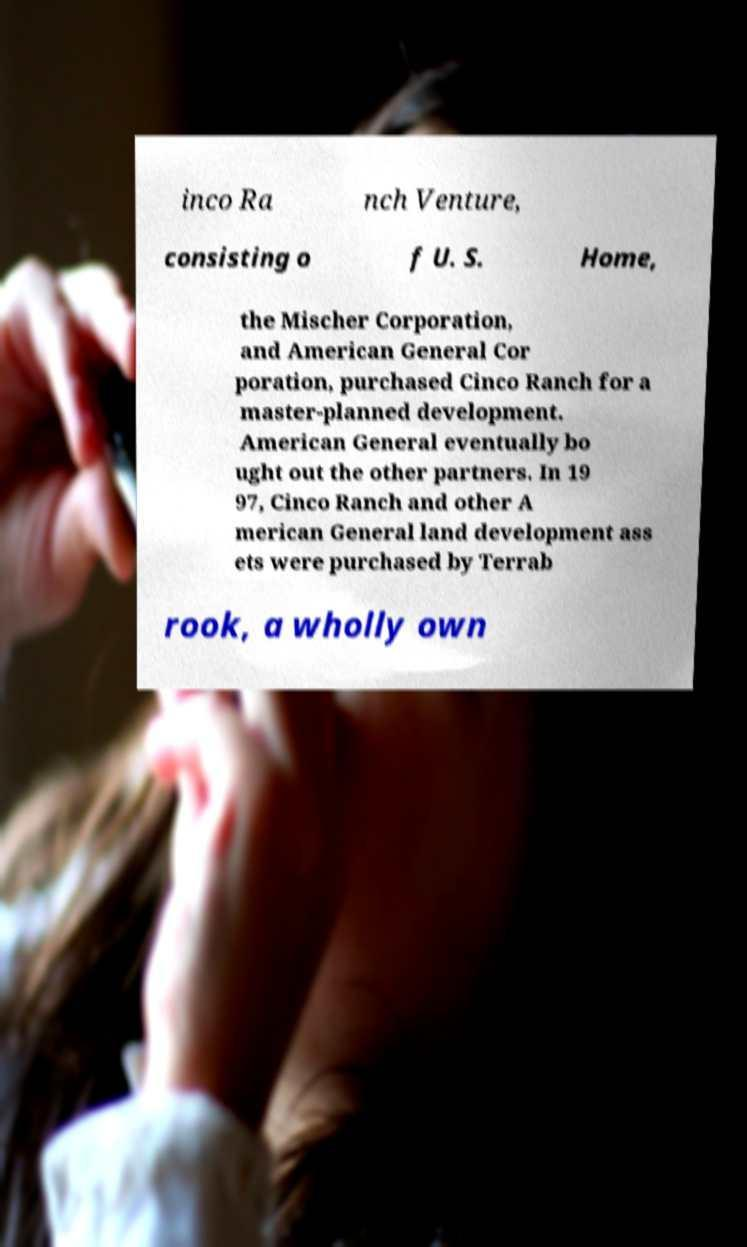What messages or text are displayed in this image? I need them in a readable, typed format. inco Ra nch Venture, consisting o f U. S. Home, the Mischer Corporation, and American General Cor poration, purchased Cinco Ranch for a master-planned development. American General eventually bo ught out the other partners. In 19 97, Cinco Ranch and other A merican General land development ass ets were purchased by Terrab rook, a wholly own 